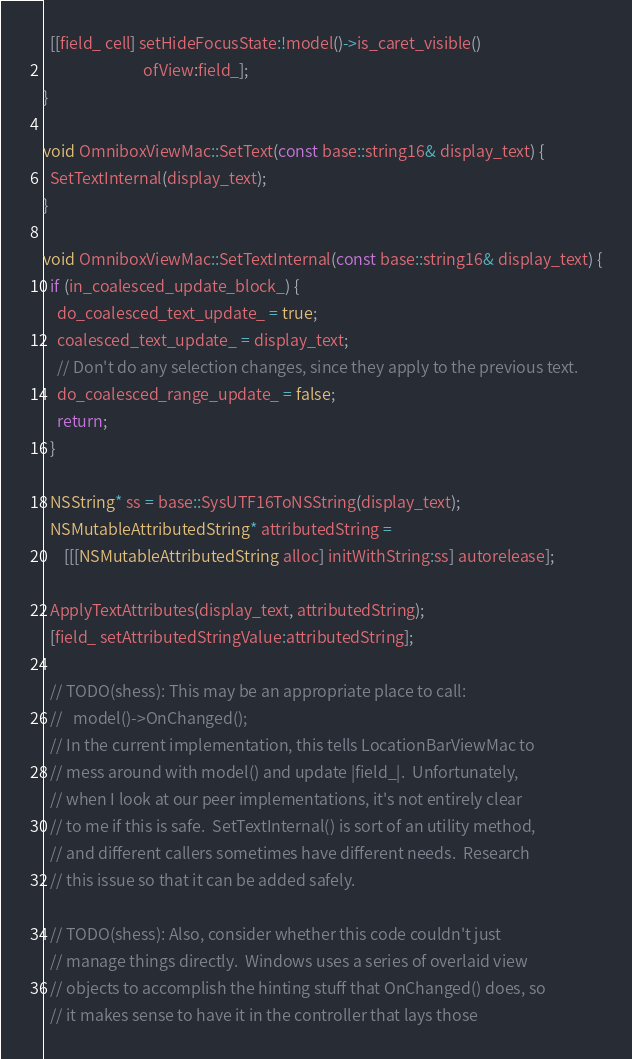Convert code to text. <code><loc_0><loc_0><loc_500><loc_500><_ObjectiveC_>  [[field_ cell] setHideFocusState:!model()->is_caret_visible()
                            ofView:field_];
}

void OmniboxViewMac::SetText(const base::string16& display_text) {
  SetTextInternal(display_text);
}

void OmniboxViewMac::SetTextInternal(const base::string16& display_text) {
  if (in_coalesced_update_block_) {
    do_coalesced_text_update_ = true;
    coalesced_text_update_ = display_text;
    // Don't do any selection changes, since they apply to the previous text.
    do_coalesced_range_update_ = false;
    return;
  }

  NSString* ss = base::SysUTF16ToNSString(display_text);
  NSMutableAttributedString* attributedString =
      [[[NSMutableAttributedString alloc] initWithString:ss] autorelease];

  ApplyTextAttributes(display_text, attributedString);
  [field_ setAttributedStringValue:attributedString];

  // TODO(shess): This may be an appropriate place to call:
  //   model()->OnChanged();
  // In the current implementation, this tells LocationBarViewMac to
  // mess around with model() and update |field_|.  Unfortunately,
  // when I look at our peer implementations, it's not entirely clear
  // to me if this is safe.  SetTextInternal() is sort of an utility method,
  // and different callers sometimes have different needs.  Research
  // this issue so that it can be added safely.

  // TODO(shess): Also, consider whether this code couldn't just
  // manage things directly.  Windows uses a series of overlaid view
  // objects to accomplish the hinting stuff that OnChanged() does, so
  // it makes sense to have it in the controller that lays those</code> 